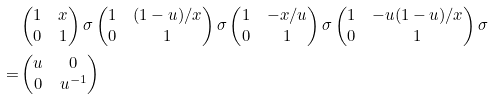<formula> <loc_0><loc_0><loc_500><loc_500>& \begin{pmatrix} 1 & x \\ 0 & 1 \end{pmatrix} \sigma \begin{pmatrix} 1 & ( 1 - u ) / x \\ 0 & 1 \end{pmatrix} \sigma \begin{pmatrix} 1 & - x / u \\ 0 & 1 \end{pmatrix} \sigma \begin{pmatrix} 1 & - u ( 1 - u ) / x \\ 0 & 1 \end{pmatrix} \sigma \\ = & \begin{pmatrix} u & 0 \\ 0 & u ^ { - 1 } \end{pmatrix}</formula> 